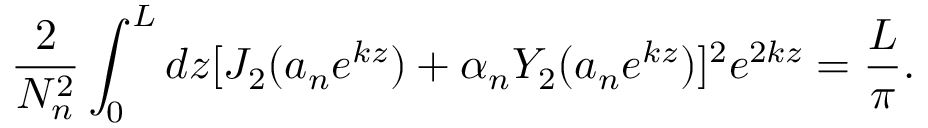Convert formula to latex. <formula><loc_0><loc_0><loc_500><loc_500>\frac { 2 } { N _ { n } ^ { 2 } } \int _ { 0 } ^ { L } d z [ J _ { 2 } ( a _ { n } e ^ { k z } ) + \alpha _ { n } Y _ { 2 } ( a _ { n } e ^ { k z } ) ] ^ { 2 } e ^ { 2 k z } = \frac { L } { \pi } .</formula> 